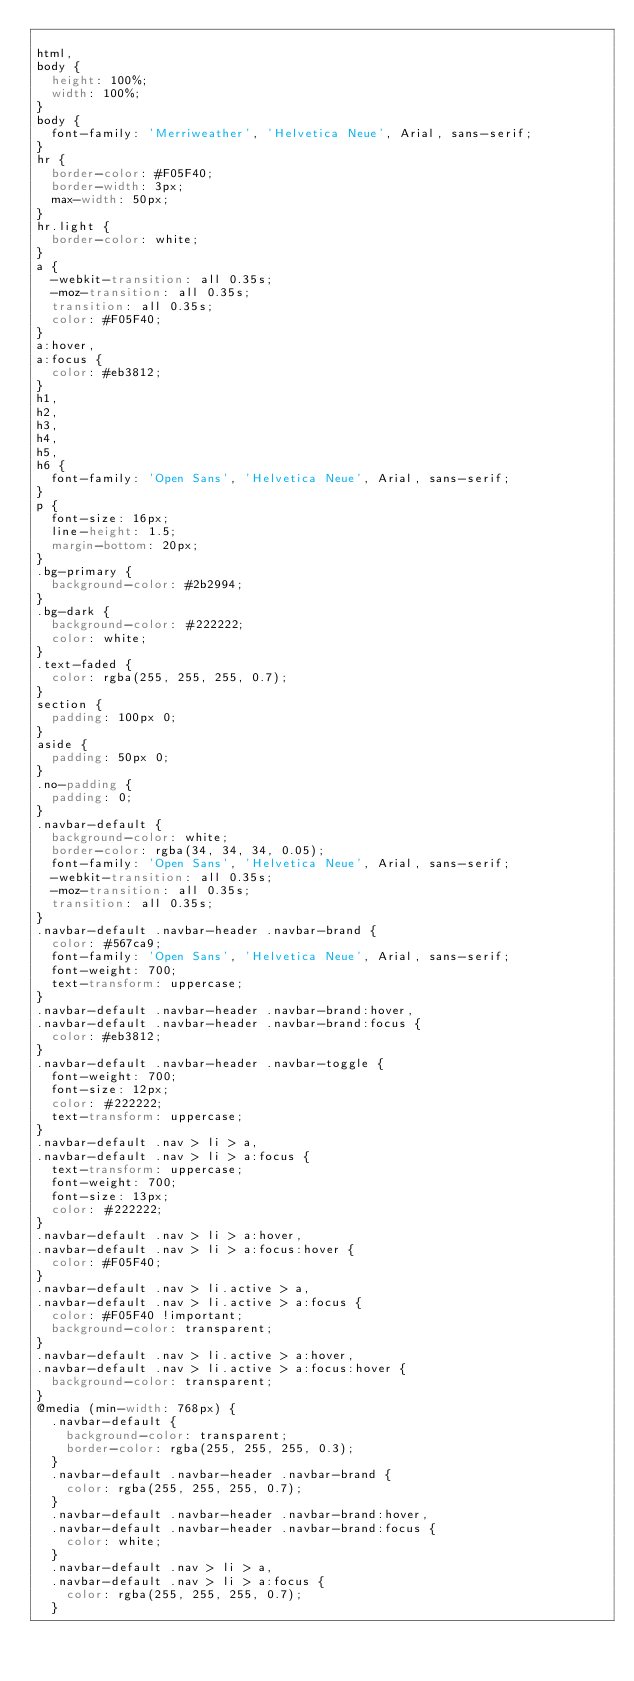Convert code to text. <code><loc_0><loc_0><loc_500><loc_500><_CSS_>
html,
body {
  height: 100%;
  width: 100%;
}
body {
  font-family: 'Merriweather', 'Helvetica Neue', Arial, sans-serif;
}
hr {
  border-color: #F05F40;
  border-width: 3px;
  max-width: 50px;
}
hr.light {
  border-color: white;
}
a {
  -webkit-transition: all 0.35s;
  -moz-transition: all 0.35s;
  transition: all 0.35s;
  color: #F05F40;
}
a:hover,
a:focus {
  color: #eb3812;
}
h1,
h2,
h3,
h4,
h5,
h6 {
  font-family: 'Open Sans', 'Helvetica Neue', Arial, sans-serif;
}
p {
  font-size: 16px;
  line-height: 1.5;
  margin-bottom: 20px;
}
.bg-primary {
  background-color: #2b2994;
}
.bg-dark {
  background-color: #222222;
  color: white;
}
.text-faded {
  color: rgba(255, 255, 255, 0.7);
}
section {
  padding: 100px 0;
}
aside {
  padding: 50px 0;
}
.no-padding {
  padding: 0;
}
.navbar-default {
  background-color: white;
  border-color: rgba(34, 34, 34, 0.05);
  font-family: 'Open Sans', 'Helvetica Neue', Arial, sans-serif;
  -webkit-transition: all 0.35s;
  -moz-transition: all 0.35s;
  transition: all 0.35s;
}
.navbar-default .navbar-header .navbar-brand {
  color: #567ca9;
  font-family: 'Open Sans', 'Helvetica Neue', Arial, sans-serif;
  font-weight: 700;
  text-transform: uppercase;
}
.navbar-default .navbar-header .navbar-brand:hover,
.navbar-default .navbar-header .navbar-brand:focus {
  color: #eb3812;
}
.navbar-default .navbar-header .navbar-toggle {
  font-weight: 700;
  font-size: 12px;
  color: #222222;
  text-transform: uppercase;
}
.navbar-default .nav > li > a,
.navbar-default .nav > li > a:focus {
  text-transform: uppercase;
  font-weight: 700;
  font-size: 13px;
  color: #222222;
}
.navbar-default .nav > li > a:hover,
.navbar-default .nav > li > a:focus:hover {
  color: #F05F40;
}
.navbar-default .nav > li.active > a,
.navbar-default .nav > li.active > a:focus {
  color: #F05F40 !important;
  background-color: transparent;
}
.navbar-default .nav > li.active > a:hover,
.navbar-default .nav > li.active > a:focus:hover {
  background-color: transparent;
}
@media (min-width: 768px) {
  .navbar-default {
    background-color: transparent;
    border-color: rgba(255, 255, 255, 0.3);
  }
  .navbar-default .navbar-header .navbar-brand {
    color: rgba(255, 255, 255, 0.7);
  }
  .navbar-default .navbar-header .navbar-brand:hover,
  .navbar-default .navbar-header .navbar-brand:focus {
    color: white;
  }
  .navbar-default .nav > li > a,
  .navbar-default .nav > li > a:focus {
    color: rgba(255, 255, 255, 0.7);
  }</code> 